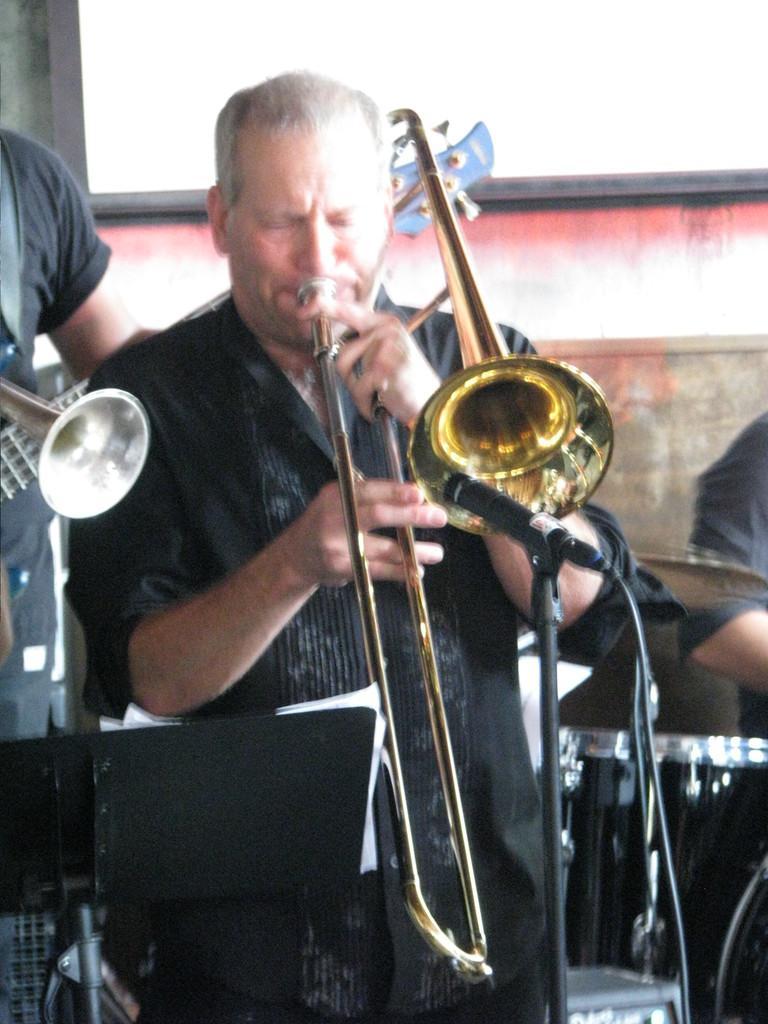In one or two sentences, can you explain what this image depicts? In the middle of the image a man is sitting and he is holding a musical instrument in his hands and playing music. On the left side of the image there is a person and there is a musical instrument. On the right side of the image there is a man and there is another musical instrument. 